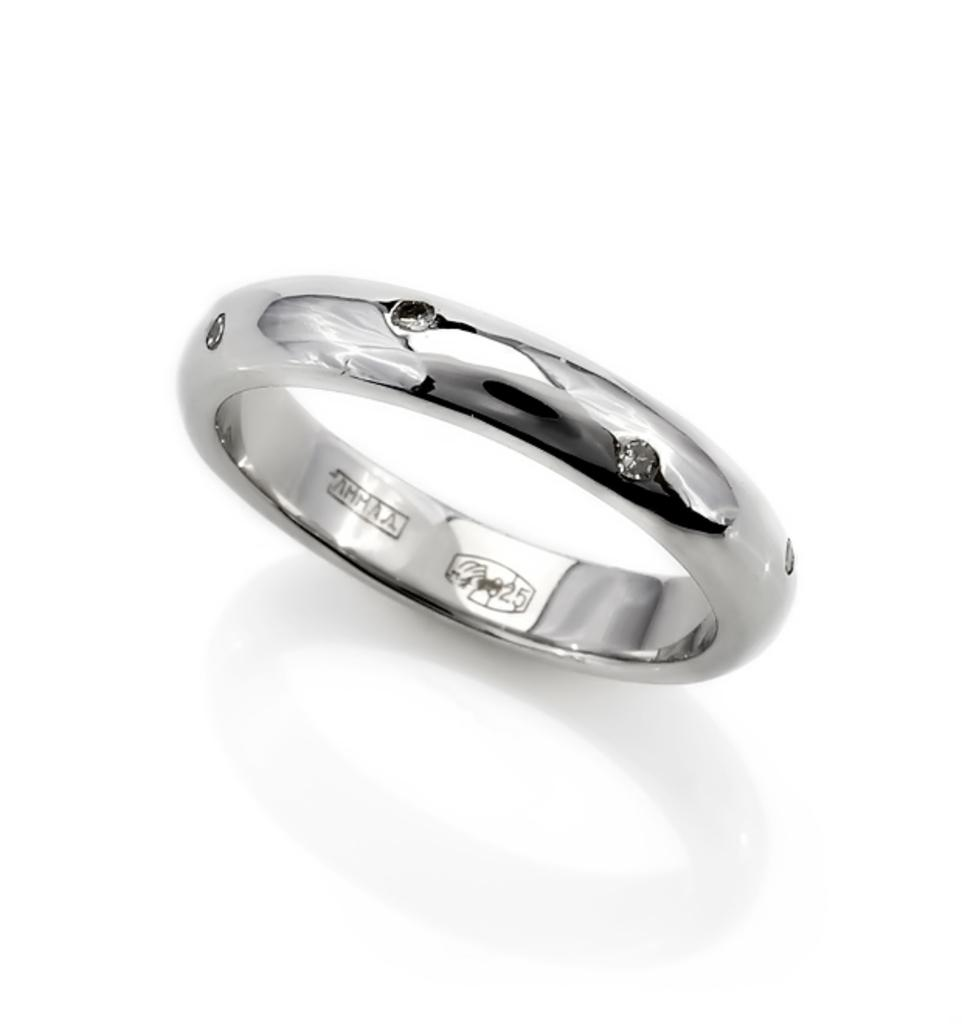What is the main subject of the image? The main subject of the image is a ring. What is the ring made of? The ring is made of silver metal. Are there any decorative elements on the ring? Yes, the ring has stones on it. Is there any text on the ring? Yes, there is text on the ring. What is the color of the background in the image? The background of the image is white. How many birds are perched on the edge of the ring in the image? There are no birds present in the image, and therefore no birds can be seen on the edge of the ring. 